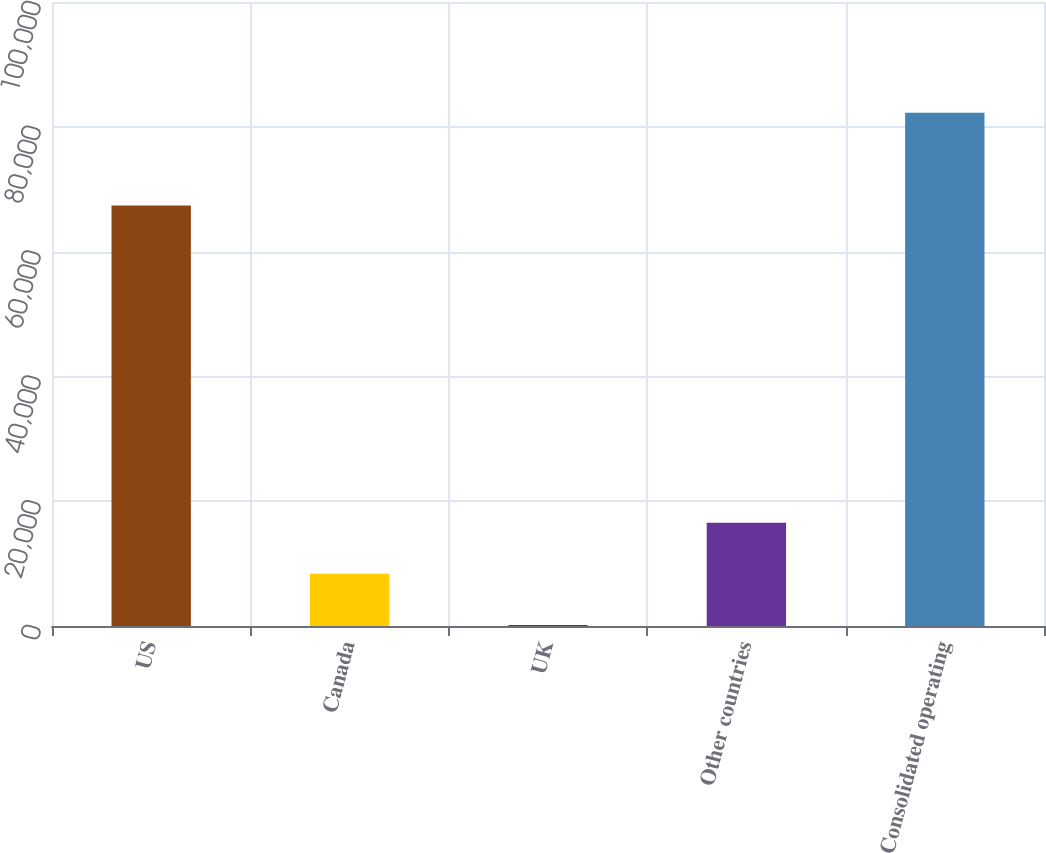<chart> <loc_0><loc_0><loc_500><loc_500><bar_chart><fcel>US<fcel>Canada<fcel>UK<fcel>Other countries<fcel>Consolidated operating<nl><fcel>67392<fcel>8357.4<fcel>149<fcel>16565.8<fcel>82233<nl></chart> 